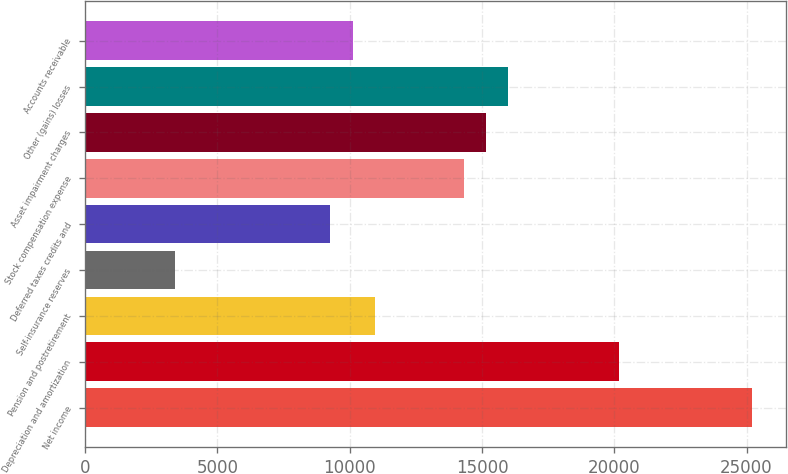Convert chart to OTSL. <chart><loc_0><loc_0><loc_500><loc_500><bar_chart><fcel>Net income<fcel>Depreciation and amortization<fcel>Pension and postretirement<fcel>Self-insurance reserves<fcel>Deferred taxes credits and<fcel>Stock compensation expense<fcel>Asset impairment charges<fcel>Other (gains) losses<fcel>Accounts receivable<nl><fcel>25216<fcel>20179<fcel>10944.5<fcel>3389<fcel>9265.5<fcel>14302.5<fcel>15142<fcel>15981.5<fcel>10105<nl></chart> 